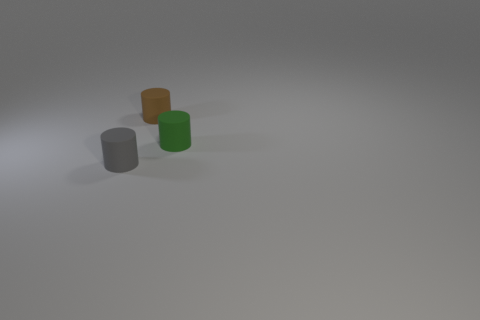The matte cylinder that is behind the small cylinder that is on the right side of the cylinder behind the tiny green matte object is what color?
Provide a succinct answer. Brown. There is a gray matte thing; are there any green cylinders on the right side of it?
Provide a succinct answer. Yes. Are there any objects that have the same material as the green cylinder?
Your answer should be very brief. Yes. Do the rubber thing left of the small brown rubber cylinder and the brown thing have the same shape?
Keep it short and to the point. Yes. What shape is the tiny rubber thing to the left of the tiny matte cylinder behind the small rubber thing right of the brown matte cylinder?
Offer a very short reply. Cylinder. Is the green rubber cylinder the same size as the brown rubber object?
Provide a short and direct response. Yes. Are there more tiny brown cylinders to the left of the brown rubber thing than tiny green cylinders to the left of the green cylinder?
Keep it short and to the point. No. How many other things are the same size as the green matte cylinder?
Provide a succinct answer. 2. Is the number of gray matte cylinders that are on the right side of the small gray rubber cylinder greater than the number of large purple blocks?
Make the answer very short. No. Are there more brown cylinders than red cylinders?
Your answer should be very brief. Yes. 